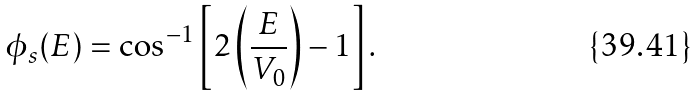<formula> <loc_0><loc_0><loc_500><loc_500>\phi _ { s } ( E ) = \cos ^ { - 1 } \left [ 2 \left ( \frac { E } { V _ { 0 } } \right ) - 1 \right ] .</formula> 